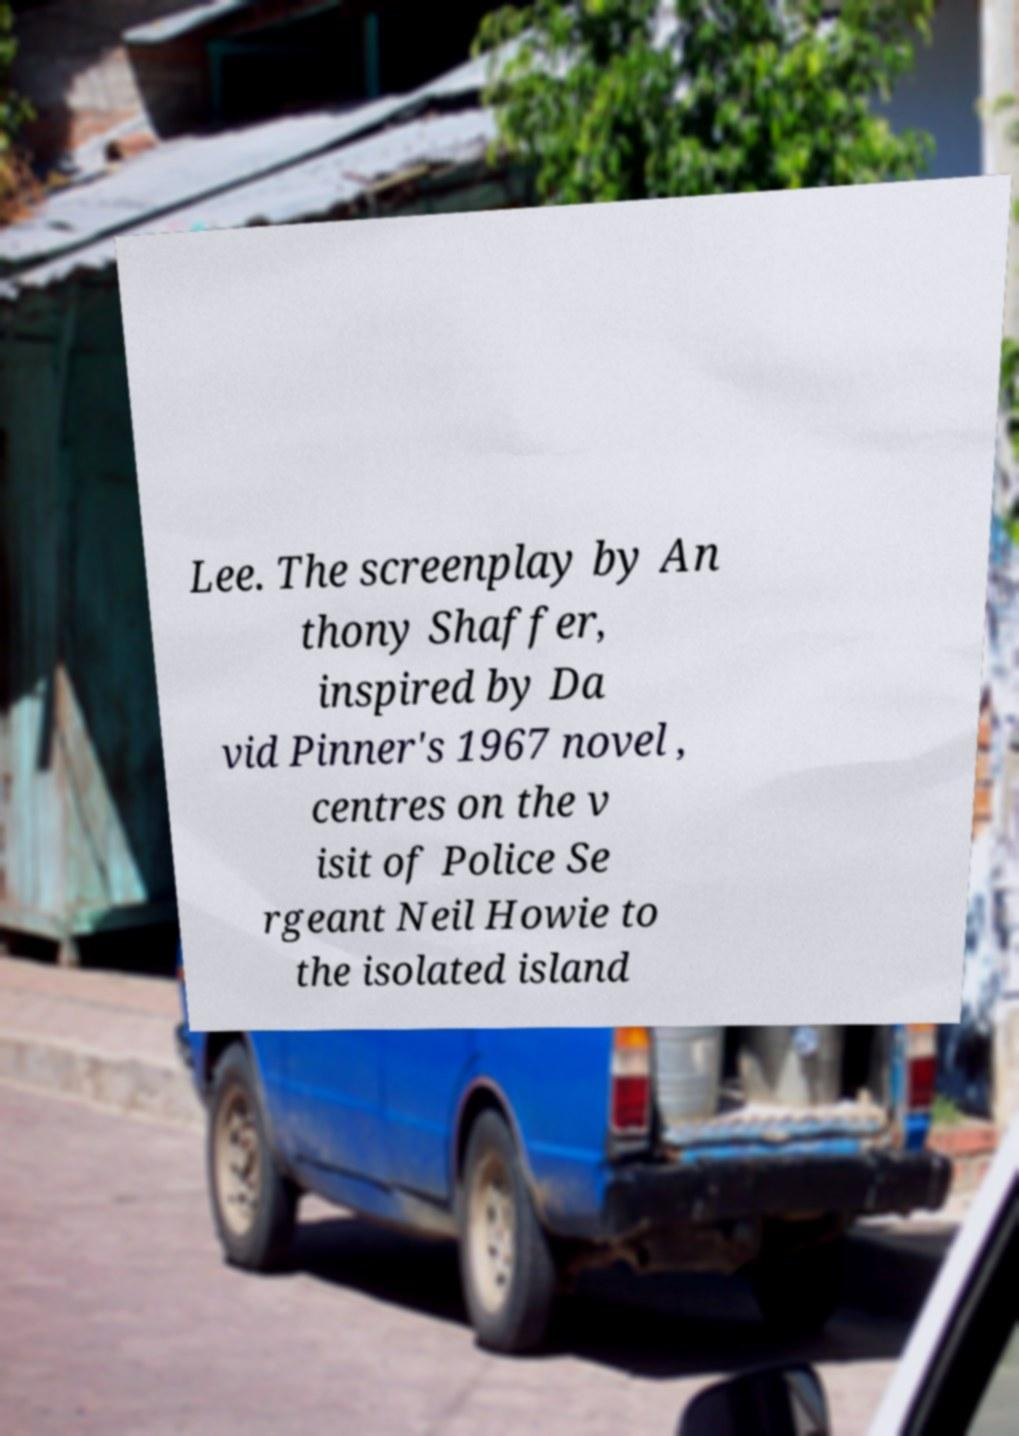Could you assist in decoding the text presented in this image and type it out clearly? Lee. The screenplay by An thony Shaffer, inspired by Da vid Pinner's 1967 novel , centres on the v isit of Police Se rgeant Neil Howie to the isolated island 